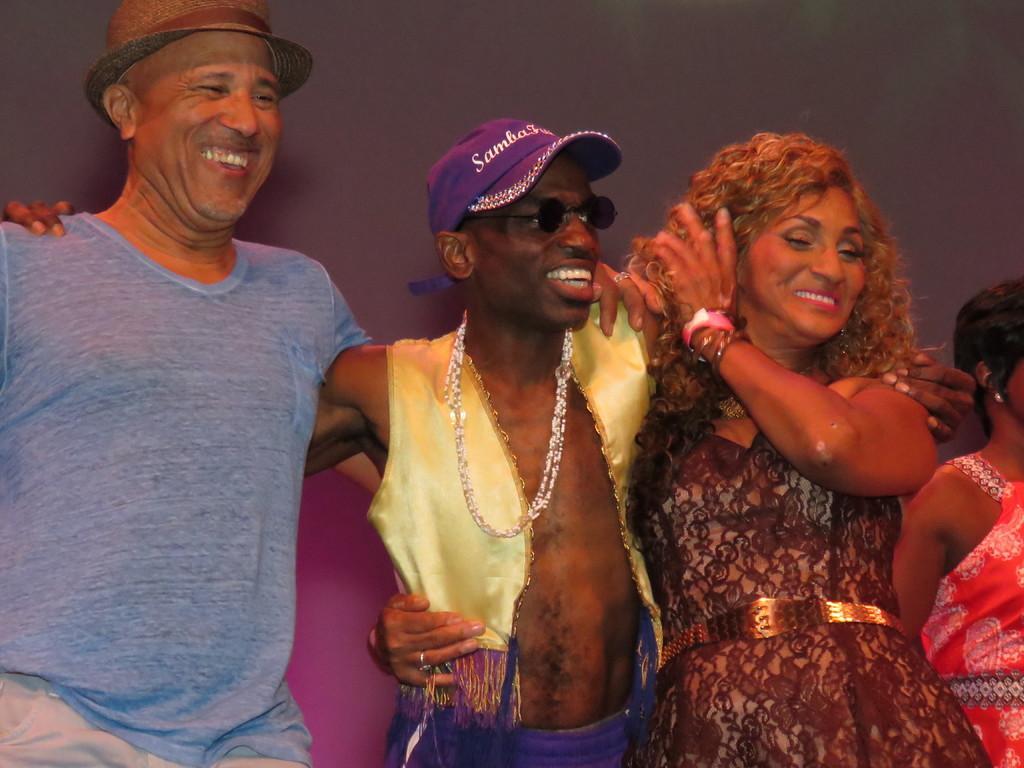Could you give a brief overview of what you see in this image? In this image I can see three persons and they are smiling. There is a woman on the extreme right side though her face is not visible. There is a man on the left side is wearing a T-shirt and there is a cap on his head. 